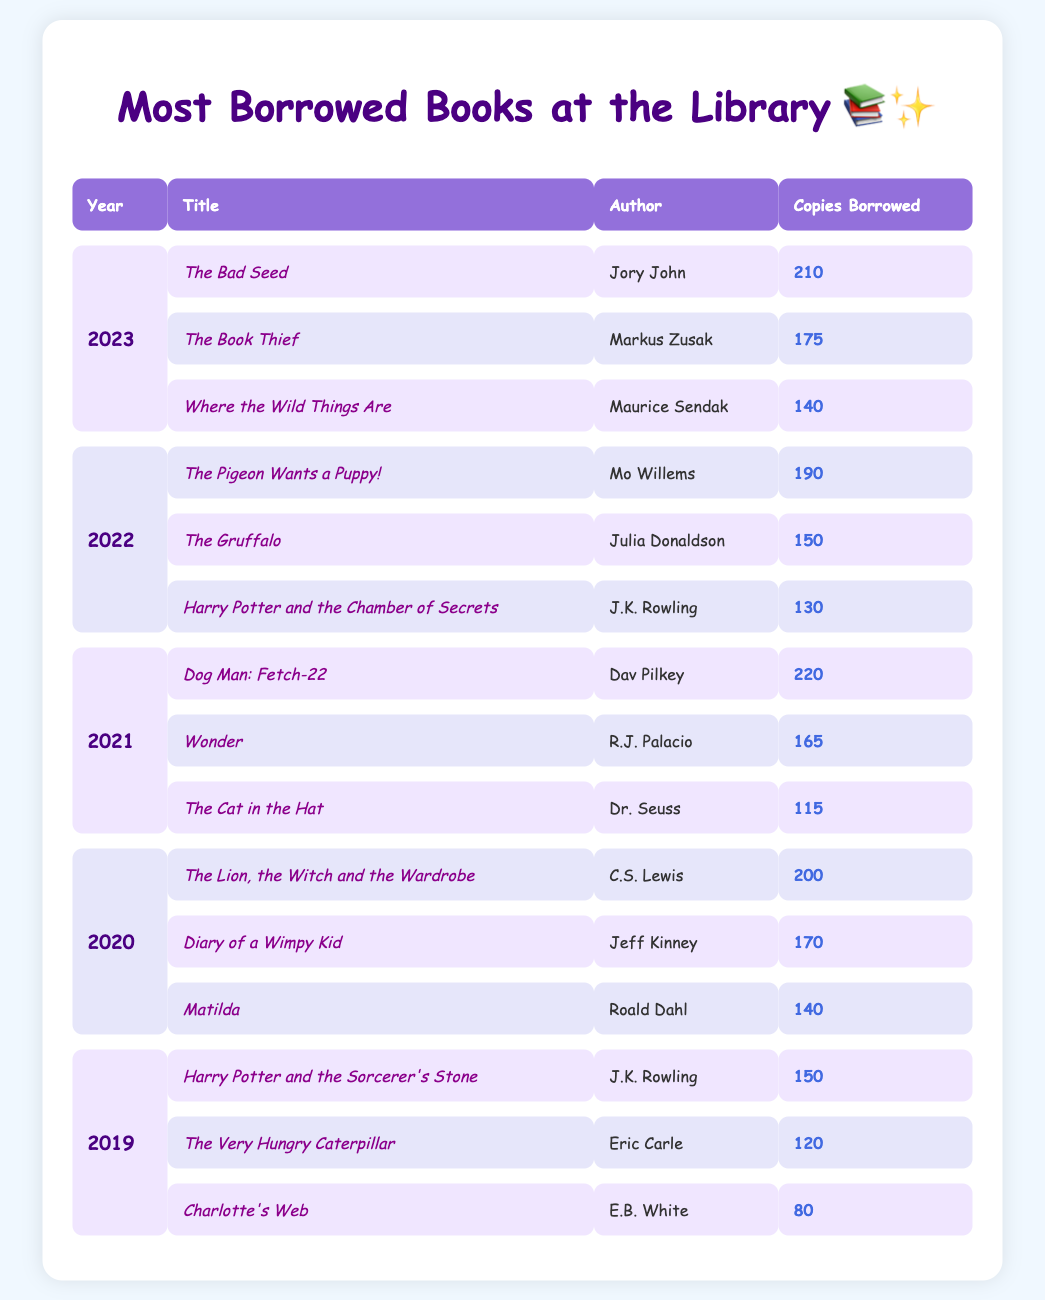What was the most borrowed book in 2021? In 2021, "Dog Man: Fetch-22" was the title with the highest copies borrowed, totaling 220.
Answer: Dog Man: Fetch-22 Who is the author of "Matilda"? "Matilda" was written by Roald Dahl, as indicated in the 2020 section of the table.
Answer: Roald Dahl Which year had the highest total copies borrowed for the top three books? To find this, we sum the copies for the top three books in each year: 2019 (150 + 120 + 80 = 350), 2020 (200 + 170 + 140 = 510), 2021 (220 + 165 + 115 = 500), 2022 (190 + 150 + 130 = 470), 2023 (210 + 175 + 140 = 525). The highest sum is 2020 with 510.
Answer: 2020 Was "Where the Wild Things Are" borrowed more than "Harry Potter and the Sorcerer's Stone"? "Where the Wild Things Are" was borrowed 140 times while "Harry Potter and the Sorcerer's Stone" was borrowed 150 times, so the statement is false.
Answer: No What is the average number of copies borrowed for the top three books in 2023? The top three books in 2023 borrowed 210, 175, and 140 copies. The sum is 210 + 175 + 140 = 525, and there are 3 books, so the average is 525 / 3 = 175.
Answer: 175 Which author's books appeared most frequently in the top three across the years? We observe J.K. Rowling appearing with two titles: "Harry Potter and the Sorcerer's Stone" in 2019 and "Harry Potter and the Chamber of Secrets" in 2022. The total counts of J.K. Rowling is 2; no other author has more than one title in the top three for their respective years.
Answer: J.K. Rowling What is the difference in copies borrowed between the most borrowed book of 2023 and 2022? The most borrowed book in 2023 is "The Bad Seed" with 210 and in 2022 is "The Pigeon Wants a Puppy!" with 190. The difference is 210 - 190 = 20.
Answer: 20 Is "The Very Hungry Caterpillar" among the top three in 2020? "The Very Hungry Caterpillar" is listed for 2019, not 2020, hence it is not among the top three for that year.
Answer: No Which book had the lowest copies borrowed in the provided data? "Charlotte's Web" had the lowest copies borrowed at 80 in 2019, as seen in the table.
Answer: Charlotte's Web What year had "Wonder" as one of its top three borrowed books? "Wonder" was in the top three in 2021, with 165 copies borrowed as listed in the table.
Answer: 2021 